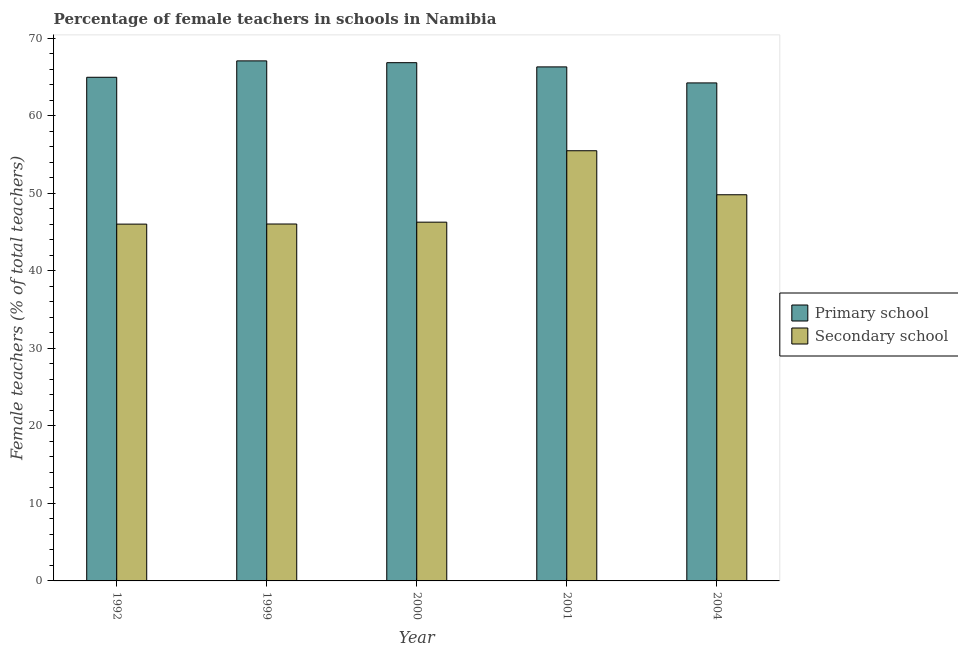How many groups of bars are there?
Keep it short and to the point. 5. Are the number of bars per tick equal to the number of legend labels?
Your response must be concise. Yes. How many bars are there on the 4th tick from the right?
Offer a terse response. 2. What is the percentage of female teachers in primary schools in 2004?
Offer a terse response. 64.22. Across all years, what is the maximum percentage of female teachers in secondary schools?
Make the answer very short. 55.47. Across all years, what is the minimum percentage of female teachers in primary schools?
Your response must be concise. 64.22. In which year was the percentage of female teachers in primary schools maximum?
Offer a terse response. 1999. In which year was the percentage of female teachers in primary schools minimum?
Offer a terse response. 2004. What is the total percentage of female teachers in secondary schools in the graph?
Provide a succinct answer. 243.57. What is the difference between the percentage of female teachers in primary schools in 2000 and that in 2001?
Your answer should be very brief. 0.54. What is the difference between the percentage of female teachers in primary schools in 2000 and the percentage of female teachers in secondary schools in 1999?
Provide a succinct answer. -0.23. What is the average percentage of female teachers in primary schools per year?
Provide a succinct answer. 65.87. In the year 2004, what is the difference between the percentage of female teachers in primary schools and percentage of female teachers in secondary schools?
Your response must be concise. 0. In how many years, is the percentage of female teachers in primary schools greater than 38 %?
Provide a short and direct response. 5. What is the ratio of the percentage of female teachers in secondary schools in 2000 to that in 2004?
Your response must be concise. 0.93. Is the percentage of female teachers in secondary schools in 1992 less than that in 2000?
Offer a very short reply. Yes. What is the difference between the highest and the second highest percentage of female teachers in secondary schools?
Offer a terse response. 5.68. What is the difference between the highest and the lowest percentage of female teachers in secondary schools?
Provide a short and direct response. 9.46. Is the sum of the percentage of female teachers in primary schools in 1999 and 2004 greater than the maximum percentage of female teachers in secondary schools across all years?
Your response must be concise. Yes. What does the 1st bar from the left in 2000 represents?
Offer a terse response. Primary school. What does the 2nd bar from the right in 2000 represents?
Make the answer very short. Primary school. How many bars are there?
Your response must be concise. 10. Are all the bars in the graph horizontal?
Your answer should be very brief. No. Where does the legend appear in the graph?
Give a very brief answer. Center right. How are the legend labels stacked?
Ensure brevity in your answer.  Vertical. What is the title of the graph?
Make the answer very short. Percentage of female teachers in schools in Namibia. What is the label or title of the Y-axis?
Give a very brief answer. Female teachers (% of total teachers). What is the Female teachers (% of total teachers) in Primary school in 1992?
Offer a terse response. 64.95. What is the Female teachers (% of total teachers) in Secondary school in 1992?
Provide a succinct answer. 46.01. What is the Female teachers (% of total teachers) in Primary school in 1999?
Your answer should be very brief. 67.06. What is the Female teachers (% of total teachers) in Secondary school in 1999?
Your answer should be very brief. 46.03. What is the Female teachers (% of total teachers) of Primary school in 2000?
Give a very brief answer. 66.83. What is the Female teachers (% of total teachers) of Secondary school in 2000?
Your response must be concise. 46.26. What is the Female teachers (% of total teachers) in Primary school in 2001?
Provide a succinct answer. 66.29. What is the Female teachers (% of total teachers) of Secondary school in 2001?
Your answer should be compact. 55.47. What is the Female teachers (% of total teachers) in Primary school in 2004?
Offer a very short reply. 64.22. What is the Female teachers (% of total teachers) of Secondary school in 2004?
Provide a succinct answer. 49.8. Across all years, what is the maximum Female teachers (% of total teachers) of Primary school?
Your answer should be compact. 67.06. Across all years, what is the maximum Female teachers (% of total teachers) of Secondary school?
Give a very brief answer. 55.47. Across all years, what is the minimum Female teachers (% of total teachers) of Primary school?
Your response must be concise. 64.22. Across all years, what is the minimum Female teachers (% of total teachers) of Secondary school?
Offer a terse response. 46.01. What is the total Female teachers (% of total teachers) in Primary school in the graph?
Offer a terse response. 329.34. What is the total Female teachers (% of total teachers) in Secondary school in the graph?
Give a very brief answer. 243.57. What is the difference between the Female teachers (% of total teachers) in Primary school in 1992 and that in 1999?
Provide a short and direct response. -2.12. What is the difference between the Female teachers (% of total teachers) in Secondary school in 1992 and that in 1999?
Provide a short and direct response. -0.01. What is the difference between the Female teachers (% of total teachers) of Primary school in 1992 and that in 2000?
Your response must be concise. -1.88. What is the difference between the Female teachers (% of total teachers) of Secondary school in 1992 and that in 2000?
Provide a succinct answer. -0.25. What is the difference between the Female teachers (% of total teachers) of Primary school in 1992 and that in 2001?
Your answer should be very brief. -1.34. What is the difference between the Female teachers (% of total teachers) of Secondary school in 1992 and that in 2001?
Provide a short and direct response. -9.46. What is the difference between the Female teachers (% of total teachers) of Primary school in 1992 and that in 2004?
Make the answer very short. 0.73. What is the difference between the Female teachers (% of total teachers) in Secondary school in 1992 and that in 2004?
Offer a very short reply. -3.79. What is the difference between the Female teachers (% of total teachers) in Primary school in 1999 and that in 2000?
Make the answer very short. 0.23. What is the difference between the Female teachers (% of total teachers) of Secondary school in 1999 and that in 2000?
Your response must be concise. -0.24. What is the difference between the Female teachers (% of total teachers) in Primary school in 1999 and that in 2001?
Offer a very short reply. 0.78. What is the difference between the Female teachers (% of total teachers) of Secondary school in 1999 and that in 2001?
Your answer should be very brief. -9.45. What is the difference between the Female teachers (% of total teachers) in Primary school in 1999 and that in 2004?
Your answer should be compact. 2.84. What is the difference between the Female teachers (% of total teachers) in Secondary school in 1999 and that in 2004?
Offer a very short reply. -3.77. What is the difference between the Female teachers (% of total teachers) of Primary school in 2000 and that in 2001?
Make the answer very short. 0.54. What is the difference between the Female teachers (% of total teachers) of Secondary school in 2000 and that in 2001?
Keep it short and to the point. -9.21. What is the difference between the Female teachers (% of total teachers) of Primary school in 2000 and that in 2004?
Keep it short and to the point. 2.61. What is the difference between the Female teachers (% of total teachers) in Secondary school in 2000 and that in 2004?
Offer a terse response. -3.53. What is the difference between the Female teachers (% of total teachers) in Primary school in 2001 and that in 2004?
Keep it short and to the point. 2.07. What is the difference between the Female teachers (% of total teachers) of Secondary school in 2001 and that in 2004?
Give a very brief answer. 5.68. What is the difference between the Female teachers (% of total teachers) in Primary school in 1992 and the Female teachers (% of total teachers) in Secondary school in 1999?
Your answer should be compact. 18.92. What is the difference between the Female teachers (% of total teachers) of Primary school in 1992 and the Female teachers (% of total teachers) of Secondary school in 2000?
Offer a very short reply. 18.68. What is the difference between the Female teachers (% of total teachers) of Primary school in 1992 and the Female teachers (% of total teachers) of Secondary school in 2001?
Provide a short and direct response. 9.47. What is the difference between the Female teachers (% of total teachers) in Primary school in 1992 and the Female teachers (% of total teachers) in Secondary school in 2004?
Offer a terse response. 15.15. What is the difference between the Female teachers (% of total teachers) in Primary school in 1999 and the Female teachers (% of total teachers) in Secondary school in 2000?
Provide a short and direct response. 20.8. What is the difference between the Female teachers (% of total teachers) of Primary school in 1999 and the Female teachers (% of total teachers) of Secondary school in 2001?
Ensure brevity in your answer.  11.59. What is the difference between the Female teachers (% of total teachers) of Primary school in 1999 and the Female teachers (% of total teachers) of Secondary school in 2004?
Give a very brief answer. 17.27. What is the difference between the Female teachers (% of total teachers) in Primary school in 2000 and the Female teachers (% of total teachers) in Secondary school in 2001?
Provide a succinct answer. 11.35. What is the difference between the Female teachers (% of total teachers) in Primary school in 2000 and the Female teachers (% of total teachers) in Secondary school in 2004?
Offer a terse response. 17.03. What is the difference between the Female teachers (% of total teachers) of Primary school in 2001 and the Female teachers (% of total teachers) of Secondary school in 2004?
Your answer should be very brief. 16.49. What is the average Female teachers (% of total teachers) of Primary school per year?
Offer a terse response. 65.87. What is the average Female teachers (% of total teachers) of Secondary school per year?
Give a very brief answer. 48.71. In the year 1992, what is the difference between the Female teachers (% of total teachers) in Primary school and Female teachers (% of total teachers) in Secondary school?
Provide a short and direct response. 18.94. In the year 1999, what is the difference between the Female teachers (% of total teachers) in Primary school and Female teachers (% of total teachers) in Secondary school?
Keep it short and to the point. 21.04. In the year 2000, what is the difference between the Female teachers (% of total teachers) of Primary school and Female teachers (% of total teachers) of Secondary school?
Provide a succinct answer. 20.57. In the year 2001, what is the difference between the Female teachers (% of total teachers) of Primary school and Female teachers (% of total teachers) of Secondary school?
Your response must be concise. 10.81. In the year 2004, what is the difference between the Female teachers (% of total teachers) of Primary school and Female teachers (% of total teachers) of Secondary school?
Provide a short and direct response. 14.42. What is the ratio of the Female teachers (% of total teachers) of Primary school in 1992 to that in 1999?
Your answer should be compact. 0.97. What is the ratio of the Female teachers (% of total teachers) of Primary school in 1992 to that in 2000?
Your answer should be compact. 0.97. What is the ratio of the Female teachers (% of total teachers) of Secondary school in 1992 to that in 2000?
Your answer should be very brief. 0.99. What is the ratio of the Female teachers (% of total teachers) of Primary school in 1992 to that in 2001?
Offer a very short reply. 0.98. What is the ratio of the Female teachers (% of total teachers) in Secondary school in 1992 to that in 2001?
Offer a terse response. 0.83. What is the ratio of the Female teachers (% of total teachers) of Primary school in 1992 to that in 2004?
Your response must be concise. 1.01. What is the ratio of the Female teachers (% of total teachers) of Secondary school in 1992 to that in 2004?
Provide a succinct answer. 0.92. What is the ratio of the Female teachers (% of total teachers) in Secondary school in 1999 to that in 2000?
Your answer should be compact. 0.99. What is the ratio of the Female teachers (% of total teachers) of Primary school in 1999 to that in 2001?
Provide a succinct answer. 1.01. What is the ratio of the Female teachers (% of total teachers) in Secondary school in 1999 to that in 2001?
Offer a very short reply. 0.83. What is the ratio of the Female teachers (% of total teachers) in Primary school in 1999 to that in 2004?
Ensure brevity in your answer.  1.04. What is the ratio of the Female teachers (% of total teachers) of Secondary school in 1999 to that in 2004?
Keep it short and to the point. 0.92. What is the ratio of the Female teachers (% of total teachers) in Primary school in 2000 to that in 2001?
Provide a succinct answer. 1.01. What is the ratio of the Female teachers (% of total teachers) in Secondary school in 2000 to that in 2001?
Your response must be concise. 0.83. What is the ratio of the Female teachers (% of total teachers) in Primary school in 2000 to that in 2004?
Ensure brevity in your answer.  1.04. What is the ratio of the Female teachers (% of total teachers) of Secondary school in 2000 to that in 2004?
Your response must be concise. 0.93. What is the ratio of the Female teachers (% of total teachers) of Primary school in 2001 to that in 2004?
Provide a succinct answer. 1.03. What is the ratio of the Female teachers (% of total teachers) in Secondary school in 2001 to that in 2004?
Make the answer very short. 1.11. What is the difference between the highest and the second highest Female teachers (% of total teachers) of Primary school?
Offer a very short reply. 0.23. What is the difference between the highest and the second highest Female teachers (% of total teachers) in Secondary school?
Your answer should be very brief. 5.68. What is the difference between the highest and the lowest Female teachers (% of total teachers) in Primary school?
Offer a terse response. 2.84. What is the difference between the highest and the lowest Female teachers (% of total teachers) of Secondary school?
Your answer should be very brief. 9.46. 